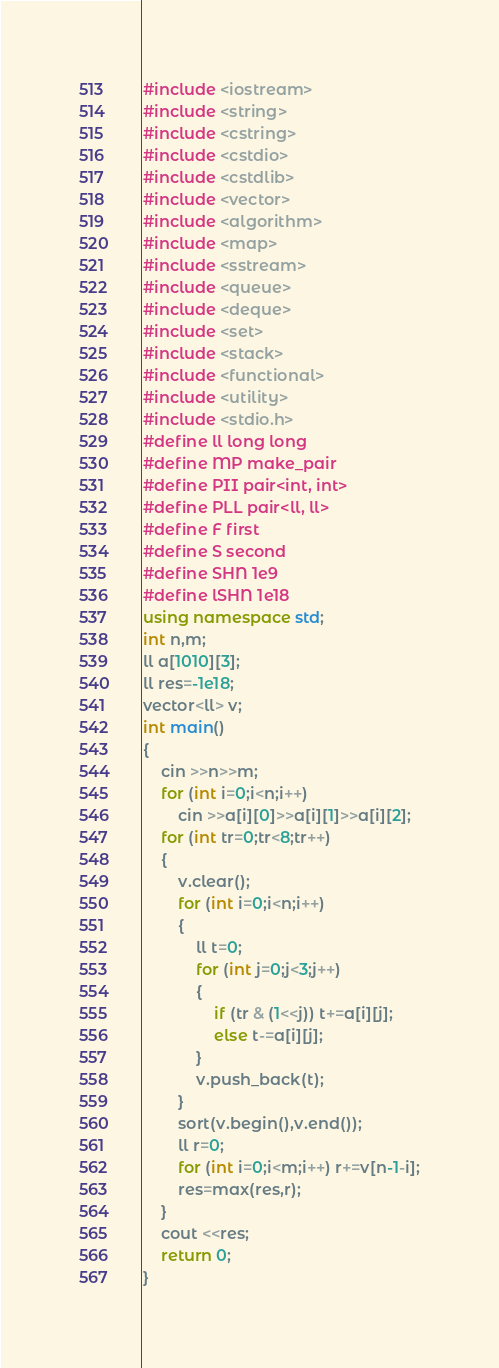<code> <loc_0><loc_0><loc_500><loc_500><_C++_>#include <iostream>
#include <string>
#include <cstring>
#include <cstdio>
#include <cstdlib>
#include <vector>
#include <algorithm>
#include <map>
#include <sstream>
#include <queue>
#include <deque>
#include <set>
#include <stack>
#include <functional>
#include <utility>
#include <stdio.h>
#define ll long long
#define MP make_pair
#define PII pair<int, int>
#define PLL pair<ll, ll>
#define F first
#define S second
#define SHN 1e9
#define lSHN 1e18
using namespace std;
int n,m;
ll a[1010][3];
ll res=-1e18;
vector<ll> v;
int main()
{
	cin >>n>>m;
	for (int i=0;i<n;i++)
	    cin >>a[i][0]>>a[i][1]>>a[i][2];
	for (int tr=0;tr<8;tr++)
	{
		v.clear();
		for (int i=0;i<n;i++)
		{
			ll t=0;
			for (int j=0;j<3;j++)
			{
				if (tr & (1<<j)) t+=a[i][j];
				else t-=a[i][j];
			}
			v.push_back(t);
		}
		sort(v.begin(),v.end());
		ll r=0;
		for (int i=0;i<m;i++) r+=v[n-1-i];
		res=max(res,r);
	}
	cout <<res;
	return 0;
} </code> 